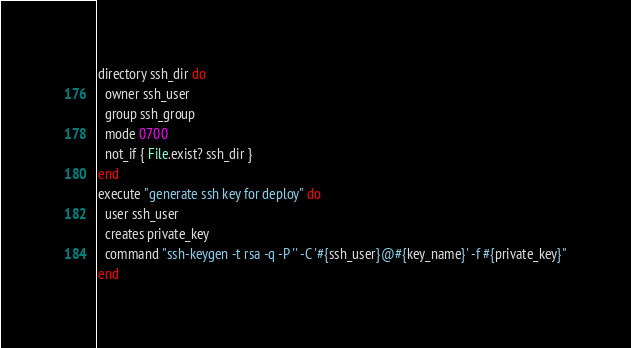Convert code to text. <code><loc_0><loc_0><loc_500><loc_500><_Ruby_>directory ssh_dir do
  owner ssh_user
  group ssh_group
  mode 0700
  not_if { File.exist? ssh_dir }
end
execute "generate ssh key for deploy" do
  user ssh_user
  creates private_key
  command "ssh-keygen -t rsa -q -P '' -C '#{ssh_user}@#{key_name}' -f #{private_key}"
end
</code> 